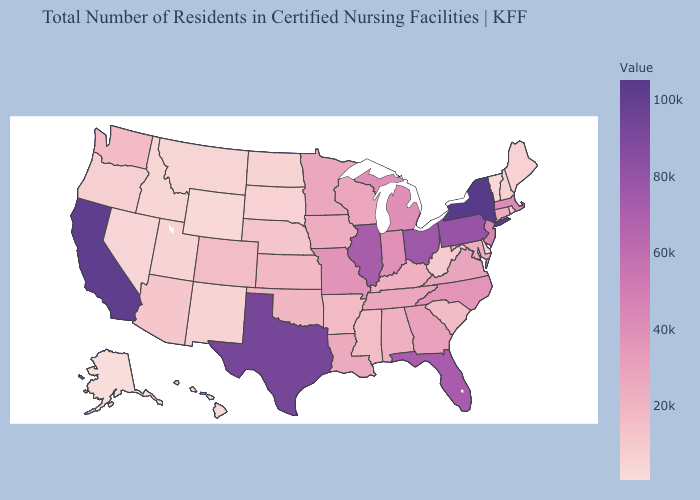Does Kentucky have the lowest value in the USA?
Keep it brief. No. Does Tennessee have the highest value in the USA?
Give a very brief answer. No. Does Kansas have a lower value than Massachusetts?
Keep it brief. Yes. Among the states that border Washington , which have the lowest value?
Answer briefly. Idaho. Does Colorado have a lower value than Delaware?
Quick response, please. No. Which states have the highest value in the USA?
Quick response, please. New York. Among the states that border Delaware , does New Jersey have the highest value?
Be succinct. No. 